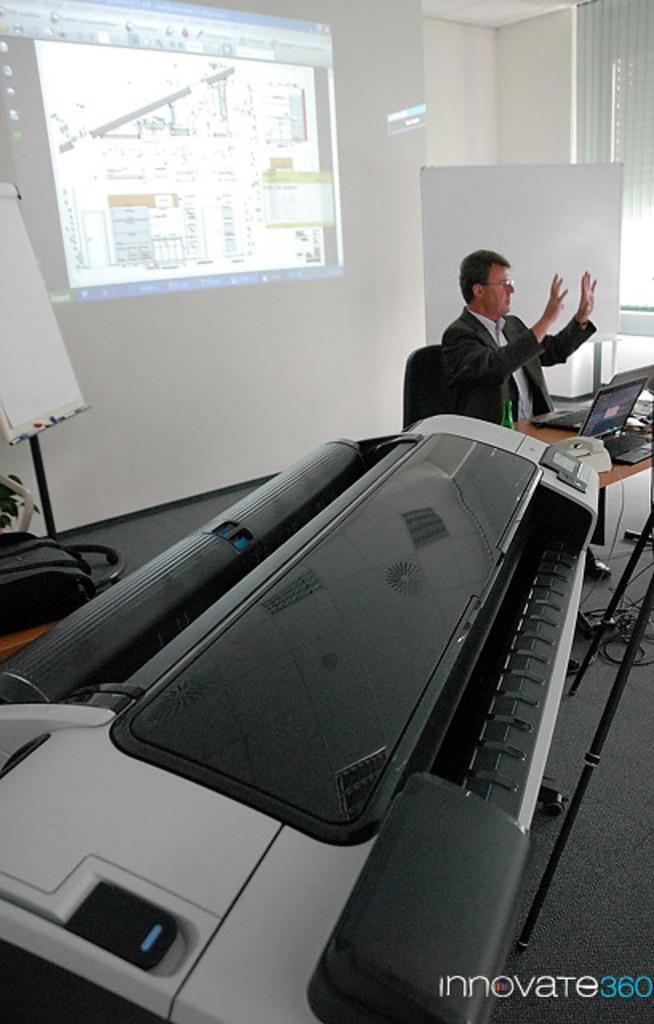How would you summarize this image in a sentence or two? This may this picture shows a man seated and speaking and we see a projector screen and a machine and we see a laptop on the table 